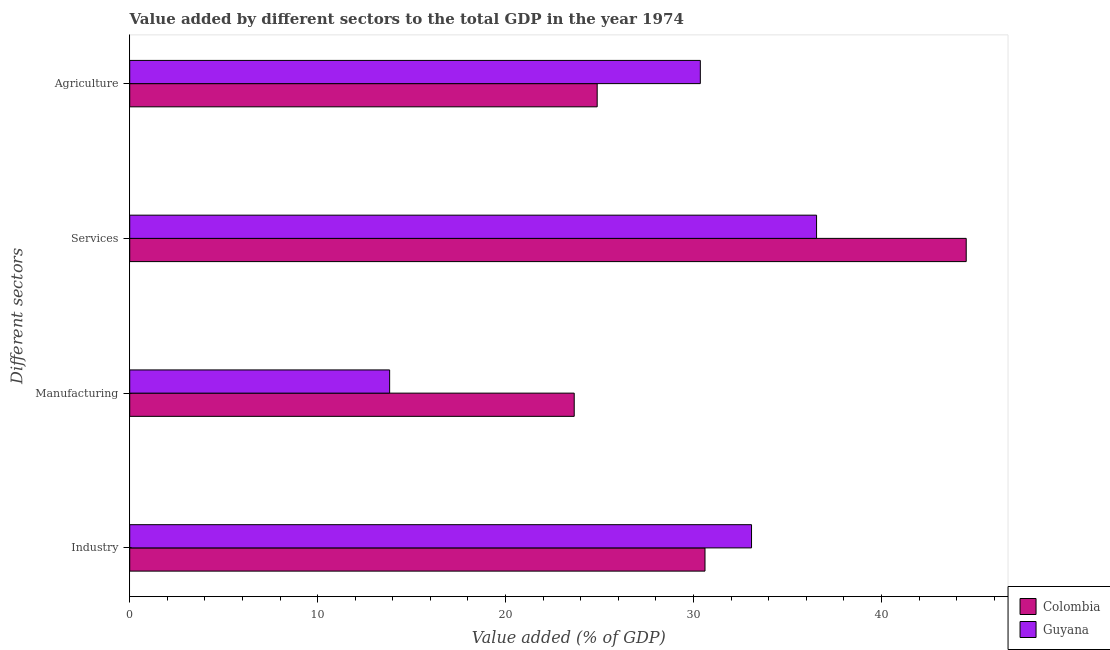How many different coloured bars are there?
Ensure brevity in your answer.  2. How many groups of bars are there?
Give a very brief answer. 4. How many bars are there on the 1st tick from the top?
Give a very brief answer. 2. How many bars are there on the 1st tick from the bottom?
Offer a terse response. 2. What is the label of the 1st group of bars from the top?
Provide a succinct answer. Agriculture. What is the value added by agricultural sector in Colombia?
Provide a short and direct response. 24.88. Across all countries, what is the maximum value added by agricultural sector?
Keep it short and to the point. 30.36. Across all countries, what is the minimum value added by manufacturing sector?
Give a very brief answer. 13.83. In which country was the value added by services sector maximum?
Offer a very short reply. Colombia. What is the total value added by manufacturing sector in the graph?
Make the answer very short. 37.48. What is the difference between the value added by industrial sector in Colombia and that in Guyana?
Make the answer very short. -2.48. What is the difference between the value added by services sector in Guyana and the value added by manufacturing sector in Colombia?
Offer a terse response. 12.9. What is the average value added by agricultural sector per country?
Your response must be concise. 27.62. What is the difference between the value added by manufacturing sector and value added by industrial sector in Colombia?
Give a very brief answer. -6.96. In how many countries, is the value added by agricultural sector greater than 14 %?
Give a very brief answer. 2. What is the ratio of the value added by agricultural sector in Colombia to that in Guyana?
Offer a very short reply. 0.82. Is the difference between the value added by industrial sector in Guyana and Colombia greater than the difference between the value added by agricultural sector in Guyana and Colombia?
Make the answer very short. No. What is the difference between the highest and the second highest value added by manufacturing sector?
Provide a short and direct response. 9.82. What is the difference between the highest and the lowest value added by manufacturing sector?
Make the answer very short. 9.82. What does the 2nd bar from the bottom in Agriculture represents?
Your response must be concise. Guyana. Is it the case that in every country, the sum of the value added by industrial sector and value added by manufacturing sector is greater than the value added by services sector?
Offer a very short reply. Yes. Does the graph contain grids?
Make the answer very short. No. Where does the legend appear in the graph?
Provide a short and direct response. Bottom right. How many legend labels are there?
Provide a short and direct response. 2. How are the legend labels stacked?
Your answer should be very brief. Vertical. What is the title of the graph?
Ensure brevity in your answer.  Value added by different sectors to the total GDP in the year 1974. What is the label or title of the X-axis?
Ensure brevity in your answer.  Value added (% of GDP). What is the label or title of the Y-axis?
Your answer should be compact. Different sectors. What is the Value added (% of GDP) in Colombia in Industry?
Make the answer very short. 30.61. What is the Value added (% of GDP) in Guyana in Industry?
Provide a short and direct response. 33.09. What is the Value added (% of GDP) of Colombia in Manufacturing?
Offer a very short reply. 23.65. What is the Value added (% of GDP) of Guyana in Manufacturing?
Ensure brevity in your answer.  13.83. What is the Value added (% of GDP) of Colombia in Services?
Keep it short and to the point. 44.51. What is the Value added (% of GDP) in Guyana in Services?
Make the answer very short. 36.55. What is the Value added (% of GDP) of Colombia in Agriculture?
Offer a very short reply. 24.88. What is the Value added (% of GDP) of Guyana in Agriculture?
Your answer should be compact. 30.36. Across all Different sectors, what is the maximum Value added (% of GDP) of Colombia?
Provide a short and direct response. 44.51. Across all Different sectors, what is the maximum Value added (% of GDP) of Guyana?
Your response must be concise. 36.55. Across all Different sectors, what is the minimum Value added (% of GDP) of Colombia?
Keep it short and to the point. 23.65. Across all Different sectors, what is the minimum Value added (% of GDP) in Guyana?
Your response must be concise. 13.83. What is the total Value added (% of GDP) in Colombia in the graph?
Offer a terse response. 123.65. What is the total Value added (% of GDP) in Guyana in the graph?
Make the answer very short. 113.83. What is the difference between the Value added (% of GDP) in Colombia in Industry and that in Manufacturing?
Provide a short and direct response. 6.96. What is the difference between the Value added (% of GDP) of Guyana in Industry and that in Manufacturing?
Provide a succinct answer. 19.26. What is the difference between the Value added (% of GDP) in Colombia in Industry and that in Services?
Your answer should be compact. -13.9. What is the difference between the Value added (% of GDP) in Guyana in Industry and that in Services?
Give a very brief answer. -3.46. What is the difference between the Value added (% of GDP) of Colombia in Industry and that in Agriculture?
Provide a short and direct response. 5.74. What is the difference between the Value added (% of GDP) in Guyana in Industry and that in Agriculture?
Your response must be concise. 2.72. What is the difference between the Value added (% of GDP) of Colombia in Manufacturing and that in Services?
Make the answer very short. -20.86. What is the difference between the Value added (% of GDP) of Guyana in Manufacturing and that in Services?
Keep it short and to the point. -22.72. What is the difference between the Value added (% of GDP) in Colombia in Manufacturing and that in Agriculture?
Your answer should be compact. -1.22. What is the difference between the Value added (% of GDP) of Guyana in Manufacturing and that in Agriculture?
Your response must be concise. -16.53. What is the difference between the Value added (% of GDP) of Colombia in Services and that in Agriculture?
Provide a short and direct response. 19.64. What is the difference between the Value added (% of GDP) of Guyana in Services and that in Agriculture?
Make the answer very short. 6.19. What is the difference between the Value added (% of GDP) in Colombia in Industry and the Value added (% of GDP) in Guyana in Manufacturing?
Provide a succinct answer. 16.78. What is the difference between the Value added (% of GDP) of Colombia in Industry and the Value added (% of GDP) of Guyana in Services?
Your response must be concise. -5.94. What is the difference between the Value added (% of GDP) in Colombia in Industry and the Value added (% of GDP) in Guyana in Agriculture?
Offer a terse response. 0.25. What is the difference between the Value added (% of GDP) in Colombia in Manufacturing and the Value added (% of GDP) in Guyana in Services?
Give a very brief answer. -12.9. What is the difference between the Value added (% of GDP) in Colombia in Manufacturing and the Value added (% of GDP) in Guyana in Agriculture?
Provide a short and direct response. -6.71. What is the difference between the Value added (% of GDP) of Colombia in Services and the Value added (% of GDP) of Guyana in Agriculture?
Your answer should be compact. 14.15. What is the average Value added (% of GDP) of Colombia per Different sectors?
Provide a short and direct response. 30.91. What is the average Value added (% of GDP) in Guyana per Different sectors?
Provide a succinct answer. 28.46. What is the difference between the Value added (% of GDP) of Colombia and Value added (% of GDP) of Guyana in Industry?
Provide a short and direct response. -2.48. What is the difference between the Value added (% of GDP) of Colombia and Value added (% of GDP) of Guyana in Manufacturing?
Provide a short and direct response. 9.82. What is the difference between the Value added (% of GDP) in Colombia and Value added (% of GDP) in Guyana in Services?
Offer a terse response. 7.96. What is the difference between the Value added (% of GDP) in Colombia and Value added (% of GDP) in Guyana in Agriculture?
Your response must be concise. -5.49. What is the ratio of the Value added (% of GDP) in Colombia in Industry to that in Manufacturing?
Provide a succinct answer. 1.29. What is the ratio of the Value added (% of GDP) in Guyana in Industry to that in Manufacturing?
Your answer should be very brief. 2.39. What is the ratio of the Value added (% of GDP) of Colombia in Industry to that in Services?
Ensure brevity in your answer.  0.69. What is the ratio of the Value added (% of GDP) of Guyana in Industry to that in Services?
Your answer should be compact. 0.91. What is the ratio of the Value added (% of GDP) of Colombia in Industry to that in Agriculture?
Provide a short and direct response. 1.23. What is the ratio of the Value added (% of GDP) of Guyana in Industry to that in Agriculture?
Provide a succinct answer. 1.09. What is the ratio of the Value added (% of GDP) in Colombia in Manufacturing to that in Services?
Keep it short and to the point. 0.53. What is the ratio of the Value added (% of GDP) of Guyana in Manufacturing to that in Services?
Keep it short and to the point. 0.38. What is the ratio of the Value added (% of GDP) in Colombia in Manufacturing to that in Agriculture?
Provide a succinct answer. 0.95. What is the ratio of the Value added (% of GDP) of Guyana in Manufacturing to that in Agriculture?
Give a very brief answer. 0.46. What is the ratio of the Value added (% of GDP) in Colombia in Services to that in Agriculture?
Provide a succinct answer. 1.79. What is the ratio of the Value added (% of GDP) in Guyana in Services to that in Agriculture?
Provide a succinct answer. 1.2. What is the difference between the highest and the second highest Value added (% of GDP) of Colombia?
Your answer should be very brief. 13.9. What is the difference between the highest and the second highest Value added (% of GDP) of Guyana?
Offer a very short reply. 3.46. What is the difference between the highest and the lowest Value added (% of GDP) in Colombia?
Provide a succinct answer. 20.86. What is the difference between the highest and the lowest Value added (% of GDP) in Guyana?
Ensure brevity in your answer.  22.72. 